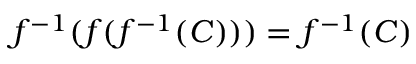Convert formula to latex. <formula><loc_0><loc_0><loc_500><loc_500>f ^ { - 1 } ( f ( f ^ { - 1 } ( C ) ) ) = f ^ { - 1 } ( C )</formula> 